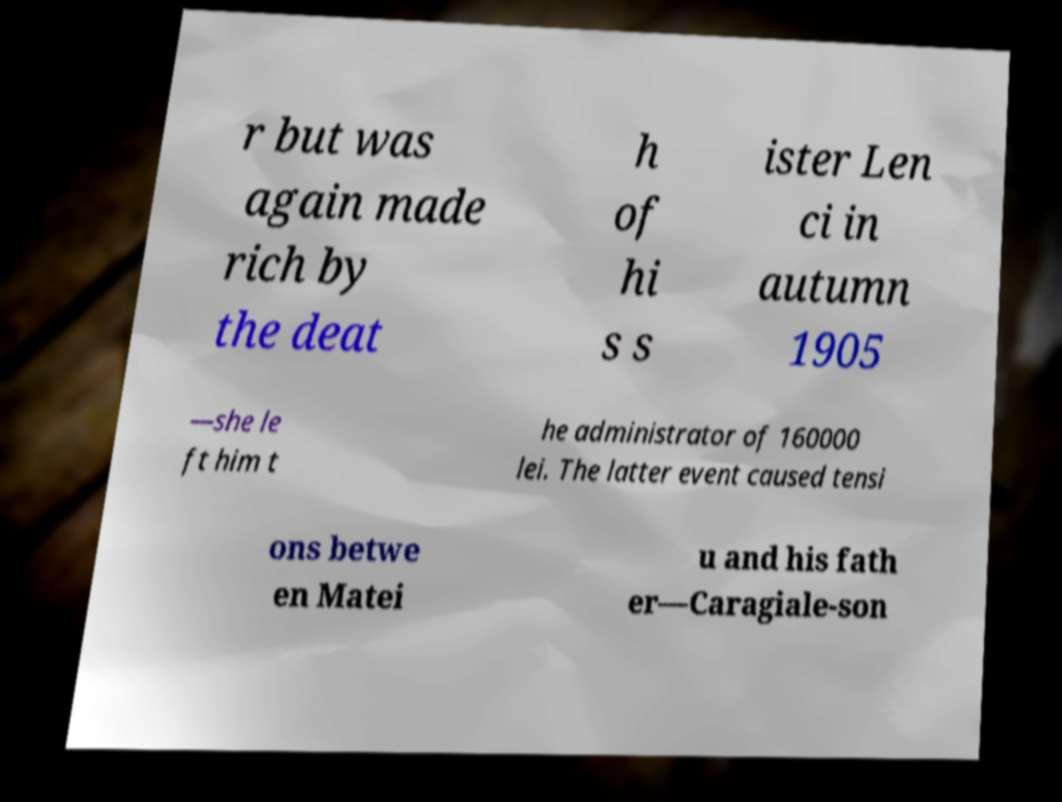Can you accurately transcribe the text from the provided image for me? r but was again made rich by the deat h of hi s s ister Len ci in autumn 1905 —she le ft him t he administrator of 160000 lei. The latter event caused tensi ons betwe en Matei u and his fath er—Caragiale-son 